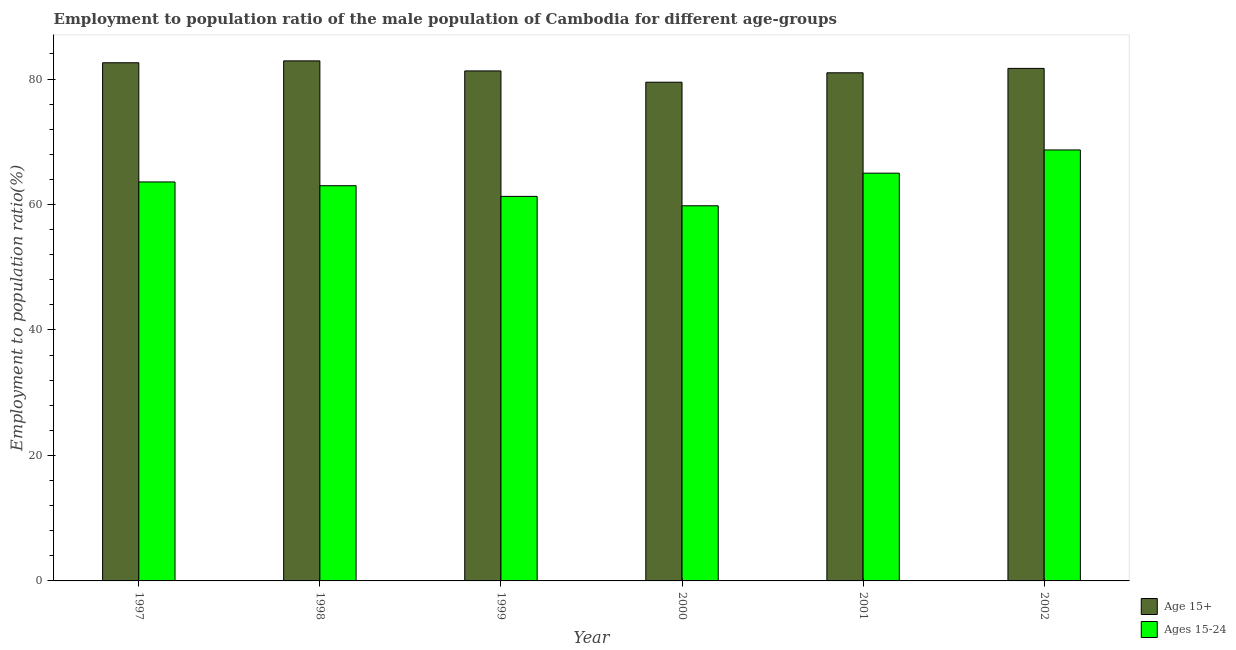How many different coloured bars are there?
Ensure brevity in your answer.  2. How many bars are there on the 1st tick from the right?
Your response must be concise. 2. In how many cases, is the number of bars for a given year not equal to the number of legend labels?
Give a very brief answer. 0. What is the employment to population ratio(age 15-24) in 1999?
Ensure brevity in your answer.  61.3. Across all years, what is the maximum employment to population ratio(age 15-24)?
Offer a terse response. 68.7. Across all years, what is the minimum employment to population ratio(age 15+)?
Ensure brevity in your answer.  79.5. What is the total employment to population ratio(age 15+) in the graph?
Provide a succinct answer. 489. What is the difference between the employment to population ratio(age 15+) in 1997 and that in 2002?
Ensure brevity in your answer.  0.9. What is the difference between the employment to population ratio(age 15-24) in 2001 and the employment to population ratio(age 15+) in 2000?
Your answer should be compact. 5.2. What is the average employment to population ratio(age 15-24) per year?
Ensure brevity in your answer.  63.57. What is the ratio of the employment to population ratio(age 15-24) in 2001 to that in 2002?
Offer a very short reply. 0.95. Is the employment to population ratio(age 15-24) in 1999 less than that in 2002?
Your answer should be compact. Yes. Is the difference between the employment to population ratio(age 15-24) in 1998 and 2001 greater than the difference between the employment to population ratio(age 15+) in 1998 and 2001?
Your response must be concise. No. What is the difference between the highest and the second highest employment to population ratio(age 15-24)?
Keep it short and to the point. 3.7. What is the difference between the highest and the lowest employment to population ratio(age 15+)?
Make the answer very short. 3.4. In how many years, is the employment to population ratio(age 15-24) greater than the average employment to population ratio(age 15-24) taken over all years?
Your answer should be compact. 3. Is the sum of the employment to population ratio(age 15+) in 2001 and 2002 greater than the maximum employment to population ratio(age 15-24) across all years?
Keep it short and to the point. Yes. What does the 2nd bar from the left in 1999 represents?
Offer a very short reply. Ages 15-24. What does the 1st bar from the right in 1997 represents?
Your answer should be very brief. Ages 15-24. Are all the bars in the graph horizontal?
Provide a short and direct response. No. What is the difference between two consecutive major ticks on the Y-axis?
Offer a terse response. 20. Does the graph contain grids?
Provide a short and direct response. No. How many legend labels are there?
Your answer should be compact. 2. What is the title of the graph?
Keep it short and to the point. Employment to population ratio of the male population of Cambodia for different age-groups. Does "From Government" appear as one of the legend labels in the graph?
Keep it short and to the point. No. What is the label or title of the X-axis?
Give a very brief answer. Year. What is the Employment to population ratio(%) in Age 15+ in 1997?
Your answer should be very brief. 82.6. What is the Employment to population ratio(%) of Ages 15-24 in 1997?
Give a very brief answer. 63.6. What is the Employment to population ratio(%) of Age 15+ in 1998?
Your response must be concise. 82.9. What is the Employment to population ratio(%) in Age 15+ in 1999?
Your answer should be very brief. 81.3. What is the Employment to population ratio(%) of Ages 15-24 in 1999?
Give a very brief answer. 61.3. What is the Employment to population ratio(%) in Age 15+ in 2000?
Give a very brief answer. 79.5. What is the Employment to population ratio(%) in Ages 15-24 in 2000?
Make the answer very short. 59.8. What is the Employment to population ratio(%) in Ages 15-24 in 2001?
Offer a terse response. 65. What is the Employment to population ratio(%) of Age 15+ in 2002?
Provide a short and direct response. 81.7. What is the Employment to population ratio(%) in Ages 15-24 in 2002?
Provide a succinct answer. 68.7. Across all years, what is the maximum Employment to population ratio(%) in Age 15+?
Provide a succinct answer. 82.9. Across all years, what is the maximum Employment to population ratio(%) of Ages 15-24?
Provide a short and direct response. 68.7. Across all years, what is the minimum Employment to population ratio(%) in Age 15+?
Your answer should be compact. 79.5. Across all years, what is the minimum Employment to population ratio(%) of Ages 15-24?
Keep it short and to the point. 59.8. What is the total Employment to population ratio(%) in Age 15+ in the graph?
Provide a succinct answer. 489. What is the total Employment to population ratio(%) of Ages 15-24 in the graph?
Provide a short and direct response. 381.4. What is the difference between the Employment to population ratio(%) of Age 15+ in 1997 and that in 1998?
Offer a terse response. -0.3. What is the difference between the Employment to population ratio(%) in Ages 15-24 in 1997 and that in 1999?
Your response must be concise. 2.3. What is the difference between the Employment to population ratio(%) in Age 15+ in 1997 and that in 2001?
Your response must be concise. 1.6. What is the difference between the Employment to population ratio(%) of Age 15+ in 1997 and that in 2002?
Make the answer very short. 0.9. What is the difference between the Employment to population ratio(%) in Age 15+ in 1998 and that in 1999?
Make the answer very short. 1.6. What is the difference between the Employment to population ratio(%) in Ages 15-24 in 1998 and that in 1999?
Your answer should be compact. 1.7. What is the difference between the Employment to population ratio(%) in Age 15+ in 1998 and that in 2000?
Provide a succinct answer. 3.4. What is the difference between the Employment to population ratio(%) in Ages 15-24 in 1998 and that in 2000?
Offer a terse response. 3.2. What is the difference between the Employment to population ratio(%) in Age 15+ in 1998 and that in 2001?
Your answer should be compact. 1.9. What is the difference between the Employment to population ratio(%) in Ages 15-24 in 1998 and that in 2001?
Your answer should be compact. -2. What is the difference between the Employment to population ratio(%) of Age 15+ in 1998 and that in 2002?
Your answer should be compact. 1.2. What is the difference between the Employment to population ratio(%) of Age 15+ in 1999 and that in 2000?
Provide a succinct answer. 1.8. What is the difference between the Employment to population ratio(%) of Ages 15-24 in 1999 and that in 2002?
Offer a very short reply. -7.4. What is the difference between the Employment to population ratio(%) in Age 15+ in 2000 and that in 2002?
Your answer should be very brief. -2.2. What is the difference between the Employment to population ratio(%) in Ages 15-24 in 2000 and that in 2002?
Offer a very short reply. -8.9. What is the difference between the Employment to population ratio(%) in Ages 15-24 in 2001 and that in 2002?
Keep it short and to the point. -3.7. What is the difference between the Employment to population ratio(%) in Age 15+ in 1997 and the Employment to population ratio(%) in Ages 15-24 in 1998?
Your response must be concise. 19.6. What is the difference between the Employment to population ratio(%) in Age 15+ in 1997 and the Employment to population ratio(%) in Ages 15-24 in 1999?
Keep it short and to the point. 21.3. What is the difference between the Employment to population ratio(%) of Age 15+ in 1997 and the Employment to population ratio(%) of Ages 15-24 in 2000?
Your answer should be very brief. 22.8. What is the difference between the Employment to population ratio(%) in Age 15+ in 1998 and the Employment to population ratio(%) in Ages 15-24 in 1999?
Provide a short and direct response. 21.6. What is the difference between the Employment to population ratio(%) in Age 15+ in 1998 and the Employment to population ratio(%) in Ages 15-24 in 2000?
Your answer should be compact. 23.1. What is the difference between the Employment to population ratio(%) of Age 15+ in 1998 and the Employment to population ratio(%) of Ages 15-24 in 2002?
Keep it short and to the point. 14.2. What is the difference between the Employment to population ratio(%) in Age 15+ in 1999 and the Employment to population ratio(%) in Ages 15-24 in 2001?
Your answer should be very brief. 16.3. What is the difference between the Employment to population ratio(%) of Age 15+ in 1999 and the Employment to population ratio(%) of Ages 15-24 in 2002?
Offer a terse response. 12.6. What is the difference between the Employment to population ratio(%) of Age 15+ in 2000 and the Employment to population ratio(%) of Ages 15-24 in 2001?
Make the answer very short. 14.5. What is the difference between the Employment to population ratio(%) in Age 15+ in 2001 and the Employment to population ratio(%) in Ages 15-24 in 2002?
Your response must be concise. 12.3. What is the average Employment to population ratio(%) of Age 15+ per year?
Make the answer very short. 81.5. What is the average Employment to population ratio(%) of Ages 15-24 per year?
Give a very brief answer. 63.57. In the year 1999, what is the difference between the Employment to population ratio(%) in Age 15+ and Employment to population ratio(%) in Ages 15-24?
Provide a short and direct response. 20. In the year 2000, what is the difference between the Employment to population ratio(%) in Age 15+ and Employment to population ratio(%) in Ages 15-24?
Keep it short and to the point. 19.7. In the year 2001, what is the difference between the Employment to population ratio(%) of Age 15+ and Employment to population ratio(%) of Ages 15-24?
Offer a terse response. 16. In the year 2002, what is the difference between the Employment to population ratio(%) of Age 15+ and Employment to population ratio(%) of Ages 15-24?
Provide a succinct answer. 13. What is the ratio of the Employment to population ratio(%) of Age 15+ in 1997 to that in 1998?
Your response must be concise. 1. What is the ratio of the Employment to population ratio(%) of Ages 15-24 in 1997 to that in 1998?
Offer a very short reply. 1.01. What is the ratio of the Employment to population ratio(%) of Ages 15-24 in 1997 to that in 1999?
Ensure brevity in your answer.  1.04. What is the ratio of the Employment to population ratio(%) in Age 15+ in 1997 to that in 2000?
Offer a very short reply. 1.04. What is the ratio of the Employment to population ratio(%) in Ages 15-24 in 1997 to that in 2000?
Offer a very short reply. 1.06. What is the ratio of the Employment to population ratio(%) of Age 15+ in 1997 to that in 2001?
Keep it short and to the point. 1.02. What is the ratio of the Employment to population ratio(%) of Ages 15-24 in 1997 to that in 2001?
Ensure brevity in your answer.  0.98. What is the ratio of the Employment to population ratio(%) in Age 15+ in 1997 to that in 2002?
Your response must be concise. 1.01. What is the ratio of the Employment to population ratio(%) of Ages 15-24 in 1997 to that in 2002?
Provide a short and direct response. 0.93. What is the ratio of the Employment to population ratio(%) in Age 15+ in 1998 to that in 1999?
Keep it short and to the point. 1.02. What is the ratio of the Employment to population ratio(%) in Ages 15-24 in 1998 to that in 1999?
Your response must be concise. 1.03. What is the ratio of the Employment to population ratio(%) of Age 15+ in 1998 to that in 2000?
Ensure brevity in your answer.  1.04. What is the ratio of the Employment to population ratio(%) in Ages 15-24 in 1998 to that in 2000?
Provide a short and direct response. 1.05. What is the ratio of the Employment to population ratio(%) in Age 15+ in 1998 to that in 2001?
Provide a short and direct response. 1.02. What is the ratio of the Employment to population ratio(%) of Ages 15-24 in 1998 to that in 2001?
Give a very brief answer. 0.97. What is the ratio of the Employment to population ratio(%) of Age 15+ in 1998 to that in 2002?
Offer a terse response. 1.01. What is the ratio of the Employment to population ratio(%) of Ages 15-24 in 1998 to that in 2002?
Offer a terse response. 0.92. What is the ratio of the Employment to population ratio(%) in Age 15+ in 1999 to that in 2000?
Offer a very short reply. 1.02. What is the ratio of the Employment to population ratio(%) of Ages 15-24 in 1999 to that in 2000?
Provide a short and direct response. 1.03. What is the ratio of the Employment to population ratio(%) in Age 15+ in 1999 to that in 2001?
Ensure brevity in your answer.  1. What is the ratio of the Employment to population ratio(%) of Ages 15-24 in 1999 to that in 2001?
Keep it short and to the point. 0.94. What is the ratio of the Employment to population ratio(%) in Ages 15-24 in 1999 to that in 2002?
Make the answer very short. 0.89. What is the ratio of the Employment to population ratio(%) in Age 15+ in 2000 to that in 2001?
Ensure brevity in your answer.  0.98. What is the ratio of the Employment to population ratio(%) in Age 15+ in 2000 to that in 2002?
Offer a very short reply. 0.97. What is the ratio of the Employment to population ratio(%) of Ages 15-24 in 2000 to that in 2002?
Provide a succinct answer. 0.87. What is the ratio of the Employment to population ratio(%) in Ages 15-24 in 2001 to that in 2002?
Offer a terse response. 0.95. What is the difference between the highest and the second highest Employment to population ratio(%) of Age 15+?
Give a very brief answer. 0.3. What is the difference between the highest and the second highest Employment to population ratio(%) in Ages 15-24?
Keep it short and to the point. 3.7. 